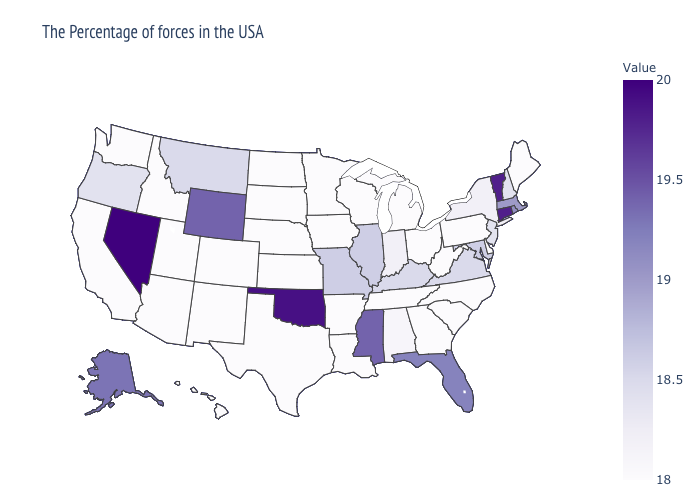Among the states that border Texas , does Oklahoma have the lowest value?
Concise answer only. No. Does Washington have the highest value in the West?
Be succinct. No. Among the states that border Mississippi , which have the lowest value?
Be succinct. Tennessee, Louisiana, Arkansas. Does the map have missing data?
Quick response, please. No. 